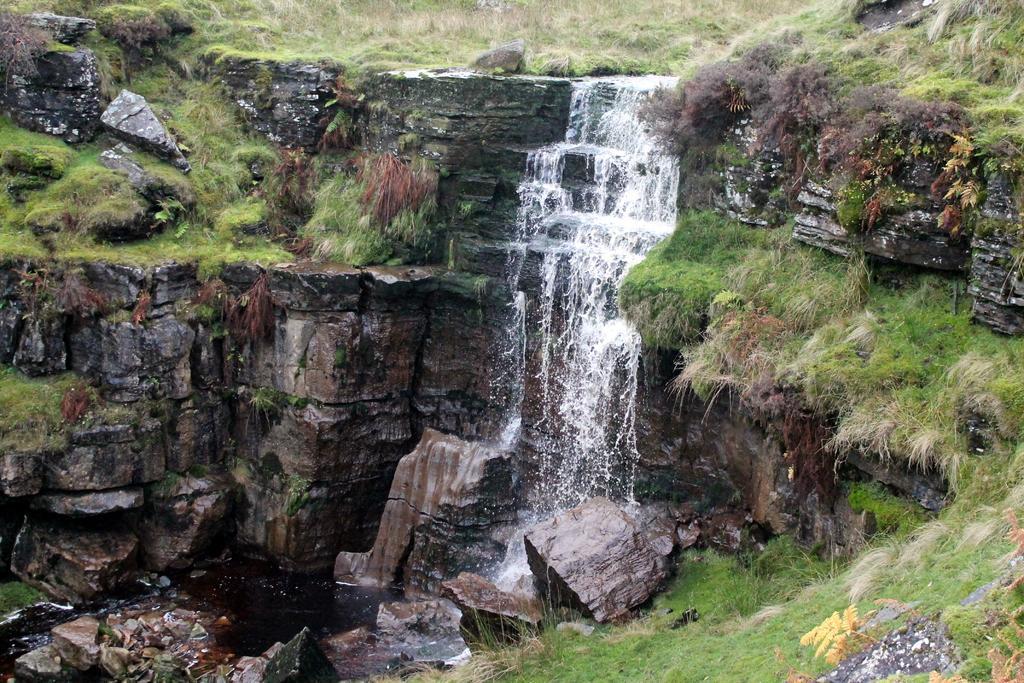Please provide a concise description of this image. In this image, we can see a waterfall and there are rocks and there is grass. 